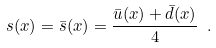Convert formula to latex. <formula><loc_0><loc_0><loc_500><loc_500>s ( x ) = \bar { s } ( x ) = \frac { \bar { u } ( x ) + \bar { d } ( x ) } { 4 } \ .</formula> 